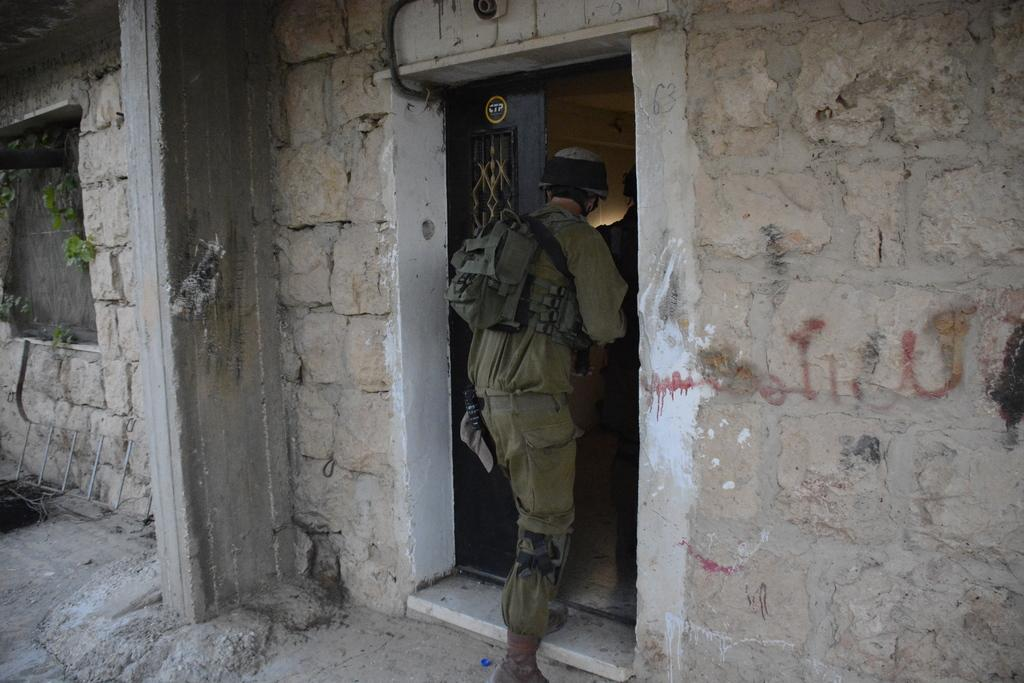What is the main structure visible in the image? There is a wall with a door in the image. Are there any other architectural features present? Yes, there is a pillar in the image. Can you describe the person in the image? There is a person in the image, and they are going inside a building. What type of suggestion can be seen written on the carriage in the image? There is no carriage present in the image, so it is not possible to answer that question. 